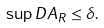Convert formula to latex. <formula><loc_0><loc_0><loc_500><loc_500>\sup _ { \ } D A _ { R } \leq \delta .</formula> 